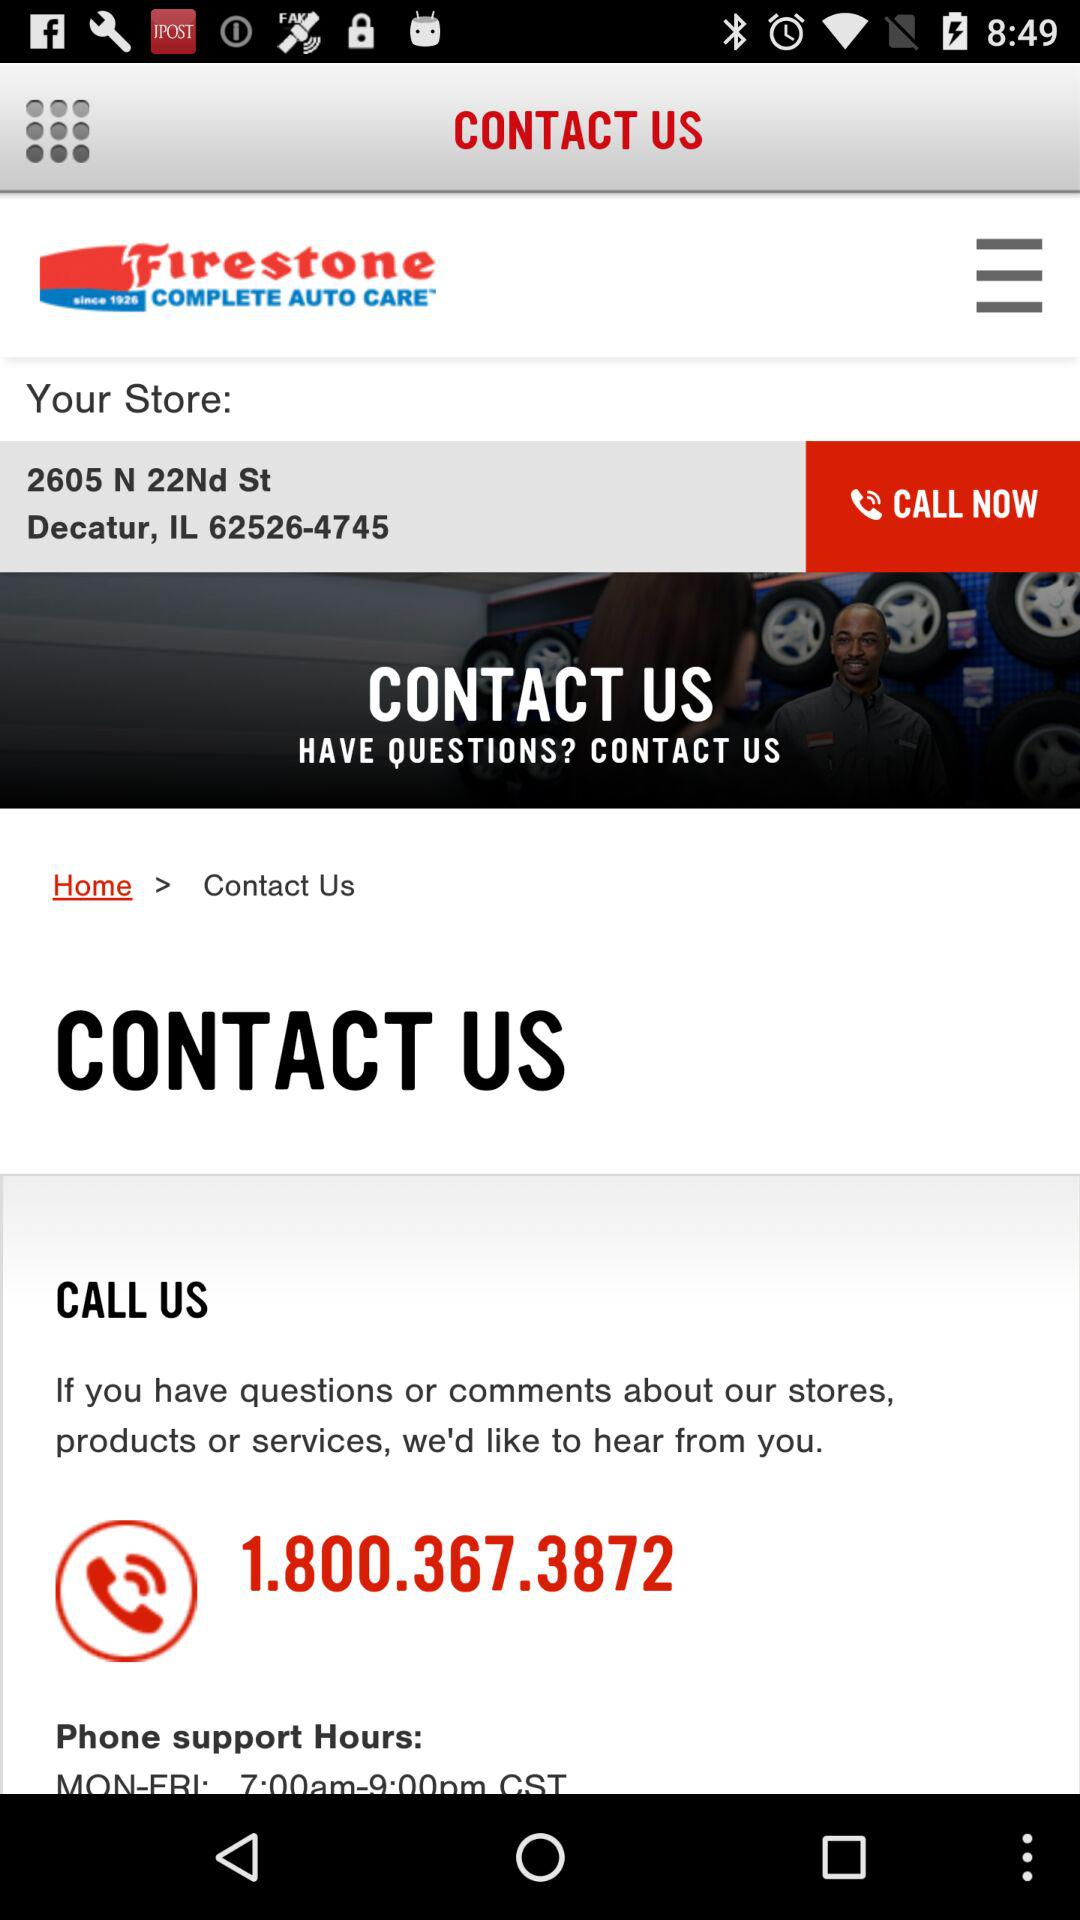How many phone numbers are there on this screen?
Answer the question using a single word or phrase. 2 